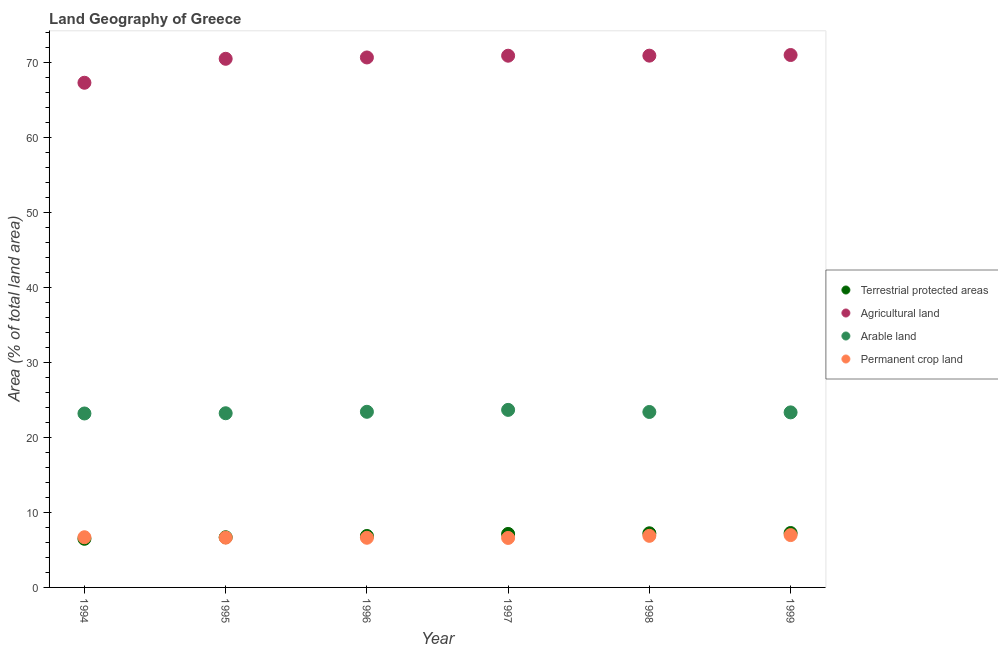How many different coloured dotlines are there?
Ensure brevity in your answer.  4. Is the number of dotlines equal to the number of legend labels?
Your answer should be very brief. Yes. What is the percentage of land under terrestrial protection in 1994?
Your answer should be very brief. 6.49. Across all years, what is the maximum percentage of area under arable land?
Provide a short and direct response. 23.69. Across all years, what is the minimum percentage of area under arable land?
Ensure brevity in your answer.  23.2. What is the total percentage of area under agricultural land in the graph?
Your answer should be compact. 421.44. What is the difference between the percentage of area under permanent crop land in 1994 and that in 1998?
Your answer should be compact. -0.19. What is the difference between the percentage of land under terrestrial protection in 1999 and the percentage of area under arable land in 1998?
Provide a short and direct response. -16.15. What is the average percentage of area under permanent crop land per year?
Offer a terse response. 6.74. In the year 1994, what is the difference between the percentage of area under permanent crop land and percentage of land under terrestrial protection?
Provide a short and direct response. 0.21. What is the ratio of the percentage of area under agricultural land in 1998 to that in 1999?
Make the answer very short. 1. What is the difference between the highest and the second highest percentage of area under arable land?
Give a very brief answer. 0.26. What is the difference between the highest and the lowest percentage of area under permanent crop land?
Make the answer very short. 0.38. Is it the case that in every year, the sum of the percentage of land under terrestrial protection and percentage of area under agricultural land is greater than the percentage of area under arable land?
Your answer should be very brief. Yes. Is the percentage of area under permanent crop land strictly greater than the percentage of land under terrestrial protection over the years?
Provide a succinct answer. No. Is the percentage of area under arable land strictly less than the percentage of land under terrestrial protection over the years?
Provide a succinct answer. No. What is the difference between two consecutive major ticks on the Y-axis?
Your answer should be compact. 10. What is the title of the graph?
Offer a very short reply. Land Geography of Greece. Does "Belgium" appear as one of the legend labels in the graph?
Provide a succinct answer. No. What is the label or title of the X-axis?
Offer a terse response. Year. What is the label or title of the Y-axis?
Your answer should be very brief. Area (% of total land area). What is the Area (% of total land area) of Terrestrial protected areas in 1994?
Your response must be concise. 6.49. What is the Area (% of total land area) of Agricultural land in 1994?
Provide a succinct answer. 67.32. What is the Area (% of total land area) of Arable land in 1994?
Provide a short and direct response. 23.2. What is the Area (% of total land area) of Permanent crop land in 1994?
Your response must be concise. 6.7. What is the Area (% of total land area) in Terrestrial protected areas in 1995?
Your answer should be compact. 6.69. What is the Area (% of total land area) in Agricultural land in 1995?
Make the answer very short. 70.52. What is the Area (% of total land area) in Arable land in 1995?
Provide a succinct answer. 23.24. What is the Area (% of total land area) in Permanent crop land in 1995?
Offer a very short reply. 6.64. What is the Area (% of total land area) of Terrestrial protected areas in 1996?
Your answer should be compact. 6.86. What is the Area (% of total land area) of Agricultural land in 1996?
Offer a terse response. 70.7. What is the Area (% of total land area) in Arable land in 1996?
Your answer should be compact. 23.43. What is the Area (% of total land area) in Permanent crop land in 1996?
Keep it short and to the point. 6.63. What is the Area (% of total land area) in Terrestrial protected areas in 1997?
Your response must be concise. 7.13. What is the Area (% of total land area) of Agricultural land in 1997?
Offer a very short reply. 70.93. What is the Area (% of total land area) of Arable land in 1997?
Provide a succinct answer. 23.69. What is the Area (% of total land area) in Permanent crop land in 1997?
Your answer should be compact. 6.6. What is the Area (% of total land area) in Terrestrial protected areas in 1998?
Provide a short and direct response. 7.22. What is the Area (% of total land area) in Agricultural land in 1998?
Give a very brief answer. 70.94. What is the Area (% of total land area) of Arable land in 1998?
Ensure brevity in your answer.  23.41. What is the Area (% of total land area) of Permanent crop land in 1998?
Keep it short and to the point. 6.88. What is the Area (% of total land area) in Terrestrial protected areas in 1999?
Your answer should be very brief. 7.26. What is the Area (% of total land area) of Agricultural land in 1999?
Your answer should be very brief. 71.02. What is the Area (% of total land area) in Arable land in 1999?
Your answer should be very brief. 23.35. What is the Area (% of total land area) in Permanent crop land in 1999?
Your answer should be very brief. 6.98. Across all years, what is the maximum Area (% of total land area) of Terrestrial protected areas?
Make the answer very short. 7.26. Across all years, what is the maximum Area (% of total land area) of Agricultural land?
Provide a short and direct response. 71.02. Across all years, what is the maximum Area (% of total land area) of Arable land?
Provide a short and direct response. 23.69. Across all years, what is the maximum Area (% of total land area) of Permanent crop land?
Your answer should be very brief. 6.98. Across all years, what is the minimum Area (% of total land area) of Terrestrial protected areas?
Provide a short and direct response. 6.49. Across all years, what is the minimum Area (% of total land area) of Agricultural land?
Your answer should be compact. 67.32. Across all years, what is the minimum Area (% of total land area) of Arable land?
Your answer should be compact. 23.2. Across all years, what is the minimum Area (% of total land area) in Permanent crop land?
Provide a short and direct response. 6.6. What is the total Area (% of total land area) of Terrestrial protected areas in the graph?
Keep it short and to the point. 41.65. What is the total Area (% of total land area) in Agricultural land in the graph?
Provide a short and direct response. 421.44. What is the total Area (% of total land area) in Arable land in the graph?
Ensure brevity in your answer.  140.31. What is the total Area (% of total land area) of Permanent crop land in the graph?
Keep it short and to the point. 40.43. What is the difference between the Area (% of total land area) of Terrestrial protected areas in 1994 and that in 1995?
Offer a terse response. -0.2. What is the difference between the Area (% of total land area) in Agricultural land in 1994 and that in 1995?
Offer a very short reply. -3.2. What is the difference between the Area (% of total land area) of Arable land in 1994 and that in 1995?
Your answer should be very brief. -0.03. What is the difference between the Area (% of total land area) in Permanent crop land in 1994 and that in 1995?
Make the answer very short. 0.05. What is the difference between the Area (% of total land area) of Terrestrial protected areas in 1994 and that in 1996?
Your answer should be compact. -0.37. What is the difference between the Area (% of total land area) in Agricultural land in 1994 and that in 1996?
Your answer should be compact. -3.37. What is the difference between the Area (% of total land area) of Arable land in 1994 and that in 1996?
Make the answer very short. -0.23. What is the difference between the Area (% of total land area) in Permanent crop land in 1994 and that in 1996?
Provide a short and direct response. 0.07. What is the difference between the Area (% of total land area) in Terrestrial protected areas in 1994 and that in 1997?
Provide a short and direct response. -0.65. What is the difference between the Area (% of total land area) of Agricultural land in 1994 and that in 1997?
Offer a very short reply. -3.61. What is the difference between the Area (% of total land area) of Arable land in 1994 and that in 1997?
Your response must be concise. -0.48. What is the difference between the Area (% of total land area) of Permanent crop land in 1994 and that in 1997?
Keep it short and to the point. 0.09. What is the difference between the Area (% of total land area) of Terrestrial protected areas in 1994 and that in 1998?
Provide a succinct answer. -0.73. What is the difference between the Area (% of total land area) of Agricultural land in 1994 and that in 1998?
Offer a terse response. -3.62. What is the difference between the Area (% of total land area) in Arable land in 1994 and that in 1998?
Your answer should be compact. -0.2. What is the difference between the Area (% of total land area) of Permanent crop land in 1994 and that in 1998?
Keep it short and to the point. -0.19. What is the difference between the Area (% of total land area) of Terrestrial protected areas in 1994 and that in 1999?
Ensure brevity in your answer.  -0.77. What is the difference between the Area (% of total land area) in Agricultural land in 1994 and that in 1999?
Your answer should be very brief. -3.7. What is the difference between the Area (% of total land area) of Arable land in 1994 and that in 1999?
Ensure brevity in your answer.  -0.15. What is the difference between the Area (% of total land area) of Permanent crop land in 1994 and that in 1999?
Give a very brief answer. -0.29. What is the difference between the Area (% of total land area) of Terrestrial protected areas in 1995 and that in 1996?
Offer a terse response. -0.17. What is the difference between the Area (% of total land area) of Agricultural land in 1995 and that in 1996?
Keep it short and to the point. -0.18. What is the difference between the Area (% of total land area) of Arable land in 1995 and that in 1996?
Give a very brief answer. -0.19. What is the difference between the Area (% of total land area) of Permanent crop land in 1995 and that in 1996?
Provide a succinct answer. 0.02. What is the difference between the Area (% of total land area) of Terrestrial protected areas in 1995 and that in 1997?
Offer a terse response. -0.44. What is the difference between the Area (% of total land area) of Agricultural land in 1995 and that in 1997?
Your answer should be compact. -0.41. What is the difference between the Area (% of total land area) in Arable land in 1995 and that in 1997?
Ensure brevity in your answer.  -0.45. What is the difference between the Area (% of total land area) in Permanent crop land in 1995 and that in 1997?
Offer a very short reply. 0.04. What is the difference between the Area (% of total land area) in Terrestrial protected areas in 1995 and that in 1998?
Offer a terse response. -0.53. What is the difference between the Area (% of total land area) in Agricultural land in 1995 and that in 1998?
Provide a short and direct response. -0.42. What is the difference between the Area (% of total land area) in Arable land in 1995 and that in 1998?
Make the answer very short. -0.17. What is the difference between the Area (% of total land area) of Permanent crop land in 1995 and that in 1998?
Offer a very short reply. -0.24. What is the difference between the Area (% of total land area) of Terrestrial protected areas in 1995 and that in 1999?
Provide a short and direct response. -0.56. What is the difference between the Area (% of total land area) in Agricultural land in 1995 and that in 1999?
Provide a succinct answer. -0.5. What is the difference between the Area (% of total land area) of Arable land in 1995 and that in 1999?
Your response must be concise. -0.12. What is the difference between the Area (% of total land area) in Permanent crop land in 1995 and that in 1999?
Offer a terse response. -0.34. What is the difference between the Area (% of total land area) of Terrestrial protected areas in 1996 and that in 1997?
Ensure brevity in your answer.  -0.27. What is the difference between the Area (% of total land area) of Agricultural land in 1996 and that in 1997?
Keep it short and to the point. -0.23. What is the difference between the Area (% of total land area) of Arable land in 1996 and that in 1997?
Provide a succinct answer. -0.26. What is the difference between the Area (% of total land area) in Permanent crop land in 1996 and that in 1997?
Offer a very short reply. 0.02. What is the difference between the Area (% of total land area) of Terrestrial protected areas in 1996 and that in 1998?
Offer a very short reply. -0.36. What is the difference between the Area (% of total land area) of Agricultural land in 1996 and that in 1998?
Provide a succinct answer. -0.24. What is the difference between the Area (% of total land area) of Arable land in 1996 and that in 1998?
Keep it short and to the point. 0.02. What is the difference between the Area (% of total land area) in Permanent crop land in 1996 and that in 1998?
Make the answer very short. -0.26. What is the difference between the Area (% of total land area) in Terrestrial protected areas in 1996 and that in 1999?
Keep it short and to the point. -0.4. What is the difference between the Area (% of total land area) of Agricultural land in 1996 and that in 1999?
Your response must be concise. -0.33. What is the difference between the Area (% of total land area) in Arable land in 1996 and that in 1999?
Your answer should be compact. 0.08. What is the difference between the Area (% of total land area) of Permanent crop land in 1996 and that in 1999?
Give a very brief answer. -0.36. What is the difference between the Area (% of total land area) in Terrestrial protected areas in 1997 and that in 1998?
Offer a terse response. -0.09. What is the difference between the Area (% of total land area) of Agricultural land in 1997 and that in 1998?
Provide a short and direct response. -0.01. What is the difference between the Area (% of total land area) in Arable land in 1997 and that in 1998?
Keep it short and to the point. 0.28. What is the difference between the Area (% of total land area) in Permanent crop land in 1997 and that in 1998?
Provide a short and direct response. -0.28. What is the difference between the Area (% of total land area) in Terrestrial protected areas in 1997 and that in 1999?
Offer a terse response. -0.12. What is the difference between the Area (% of total land area) of Agricultural land in 1997 and that in 1999?
Provide a short and direct response. -0.09. What is the difference between the Area (% of total land area) of Arable land in 1997 and that in 1999?
Make the answer very short. 0.33. What is the difference between the Area (% of total land area) of Permanent crop land in 1997 and that in 1999?
Make the answer very short. -0.38. What is the difference between the Area (% of total land area) in Terrestrial protected areas in 1998 and that in 1999?
Your answer should be very brief. -0.03. What is the difference between the Area (% of total land area) in Agricultural land in 1998 and that in 1999?
Your answer should be very brief. -0.09. What is the difference between the Area (% of total land area) of Arable land in 1998 and that in 1999?
Provide a short and direct response. 0.05. What is the difference between the Area (% of total land area) of Permanent crop land in 1998 and that in 1999?
Keep it short and to the point. -0.1. What is the difference between the Area (% of total land area) of Terrestrial protected areas in 1994 and the Area (% of total land area) of Agricultural land in 1995?
Offer a terse response. -64.03. What is the difference between the Area (% of total land area) of Terrestrial protected areas in 1994 and the Area (% of total land area) of Arable land in 1995?
Provide a short and direct response. -16.75. What is the difference between the Area (% of total land area) of Terrestrial protected areas in 1994 and the Area (% of total land area) of Permanent crop land in 1995?
Your answer should be very brief. -0.15. What is the difference between the Area (% of total land area) in Agricultural land in 1994 and the Area (% of total land area) in Arable land in 1995?
Give a very brief answer. 44.09. What is the difference between the Area (% of total land area) of Agricultural land in 1994 and the Area (% of total land area) of Permanent crop land in 1995?
Offer a terse response. 60.68. What is the difference between the Area (% of total land area) of Arable land in 1994 and the Area (% of total land area) of Permanent crop land in 1995?
Offer a terse response. 16.56. What is the difference between the Area (% of total land area) in Terrestrial protected areas in 1994 and the Area (% of total land area) in Agricultural land in 1996?
Ensure brevity in your answer.  -64.21. What is the difference between the Area (% of total land area) in Terrestrial protected areas in 1994 and the Area (% of total land area) in Arable land in 1996?
Your response must be concise. -16.94. What is the difference between the Area (% of total land area) in Terrestrial protected areas in 1994 and the Area (% of total land area) in Permanent crop land in 1996?
Your answer should be very brief. -0.14. What is the difference between the Area (% of total land area) in Agricultural land in 1994 and the Area (% of total land area) in Arable land in 1996?
Give a very brief answer. 43.89. What is the difference between the Area (% of total land area) in Agricultural land in 1994 and the Area (% of total land area) in Permanent crop land in 1996?
Ensure brevity in your answer.  60.7. What is the difference between the Area (% of total land area) in Arable land in 1994 and the Area (% of total land area) in Permanent crop land in 1996?
Provide a short and direct response. 16.58. What is the difference between the Area (% of total land area) of Terrestrial protected areas in 1994 and the Area (% of total land area) of Agricultural land in 1997?
Ensure brevity in your answer.  -64.44. What is the difference between the Area (% of total land area) in Terrestrial protected areas in 1994 and the Area (% of total land area) in Arable land in 1997?
Provide a short and direct response. -17.2. What is the difference between the Area (% of total land area) in Terrestrial protected areas in 1994 and the Area (% of total land area) in Permanent crop land in 1997?
Make the answer very short. -0.11. What is the difference between the Area (% of total land area) in Agricultural land in 1994 and the Area (% of total land area) in Arable land in 1997?
Your answer should be very brief. 43.64. What is the difference between the Area (% of total land area) of Agricultural land in 1994 and the Area (% of total land area) of Permanent crop land in 1997?
Offer a terse response. 60.72. What is the difference between the Area (% of total land area) in Arable land in 1994 and the Area (% of total land area) in Permanent crop land in 1997?
Offer a very short reply. 16.6. What is the difference between the Area (% of total land area) in Terrestrial protected areas in 1994 and the Area (% of total land area) in Agricultural land in 1998?
Make the answer very short. -64.45. What is the difference between the Area (% of total land area) of Terrestrial protected areas in 1994 and the Area (% of total land area) of Arable land in 1998?
Provide a short and direct response. -16.92. What is the difference between the Area (% of total land area) of Terrestrial protected areas in 1994 and the Area (% of total land area) of Permanent crop land in 1998?
Keep it short and to the point. -0.39. What is the difference between the Area (% of total land area) of Agricultural land in 1994 and the Area (% of total land area) of Arable land in 1998?
Your response must be concise. 43.92. What is the difference between the Area (% of total land area) in Agricultural land in 1994 and the Area (% of total land area) in Permanent crop land in 1998?
Provide a succinct answer. 60.44. What is the difference between the Area (% of total land area) in Arable land in 1994 and the Area (% of total land area) in Permanent crop land in 1998?
Offer a very short reply. 16.32. What is the difference between the Area (% of total land area) of Terrestrial protected areas in 1994 and the Area (% of total land area) of Agricultural land in 1999?
Provide a short and direct response. -64.54. What is the difference between the Area (% of total land area) of Terrestrial protected areas in 1994 and the Area (% of total land area) of Arable land in 1999?
Ensure brevity in your answer.  -16.86. What is the difference between the Area (% of total land area) of Terrestrial protected areas in 1994 and the Area (% of total land area) of Permanent crop land in 1999?
Give a very brief answer. -0.49. What is the difference between the Area (% of total land area) in Agricultural land in 1994 and the Area (% of total land area) in Arable land in 1999?
Offer a terse response. 43.97. What is the difference between the Area (% of total land area) of Agricultural land in 1994 and the Area (% of total land area) of Permanent crop land in 1999?
Give a very brief answer. 60.34. What is the difference between the Area (% of total land area) in Arable land in 1994 and the Area (% of total land area) in Permanent crop land in 1999?
Your answer should be very brief. 16.22. What is the difference between the Area (% of total land area) of Terrestrial protected areas in 1995 and the Area (% of total land area) of Agricultural land in 1996?
Offer a very short reply. -64.01. What is the difference between the Area (% of total land area) of Terrestrial protected areas in 1995 and the Area (% of total land area) of Arable land in 1996?
Offer a terse response. -16.74. What is the difference between the Area (% of total land area) of Terrestrial protected areas in 1995 and the Area (% of total land area) of Permanent crop land in 1996?
Your answer should be very brief. 0.07. What is the difference between the Area (% of total land area) in Agricultural land in 1995 and the Area (% of total land area) in Arable land in 1996?
Offer a terse response. 47.09. What is the difference between the Area (% of total land area) of Agricultural land in 1995 and the Area (% of total land area) of Permanent crop land in 1996?
Offer a terse response. 63.89. What is the difference between the Area (% of total land area) in Arable land in 1995 and the Area (% of total land area) in Permanent crop land in 1996?
Your answer should be compact. 16.61. What is the difference between the Area (% of total land area) in Terrestrial protected areas in 1995 and the Area (% of total land area) in Agricultural land in 1997?
Provide a short and direct response. -64.24. What is the difference between the Area (% of total land area) in Terrestrial protected areas in 1995 and the Area (% of total land area) in Arable land in 1997?
Keep it short and to the point. -16.99. What is the difference between the Area (% of total land area) of Terrestrial protected areas in 1995 and the Area (% of total land area) of Permanent crop land in 1997?
Ensure brevity in your answer.  0.09. What is the difference between the Area (% of total land area) in Agricultural land in 1995 and the Area (% of total land area) in Arable land in 1997?
Offer a very short reply. 46.83. What is the difference between the Area (% of total land area) of Agricultural land in 1995 and the Area (% of total land area) of Permanent crop land in 1997?
Ensure brevity in your answer.  63.92. What is the difference between the Area (% of total land area) in Arable land in 1995 and the Area (% of total land area) in Permanent crop land in 1997?
Keep it short and to the point. 16.63. What is the difference between the Area (% of total land area) of Terrestrial protected areas in 1995 and the Area (% of total land area) of Agricultural land in 1998?
Give a very brief answer. -64.25. What is the difference between the Area (% of total land area) of Terrestrial protected areas in 1995 and the Area (% of total land area) of Arable land in 1998?
Your answer should be compact. -16.71. What is the difference between the Area (% of total land area) of Terrestrial protected areas in 1995 and the Area (% of total land area) of Permanent crop land in 1998?
Your response must be concise. -0.19. What is the difference between the Area (% of total land area) in Agricultural land in 1995 and the Area (% of total land area) in Arable land in 1998?
Provide a succinct answer. 47.11. What is the difference between the Area (% of total land area) of Agricultural land in 1995 and the Area (% of total land area) of Permanent crop land in 1998?
Offer a very short reply. 63.64. What is the difference between the Area (% of total land area) in Arable land in 1995 and the Area (% of total land area) in Permanent crop land in 1998?
Offer a very short reply. 16.35. What is the difference between the Area (% of total land area) in Terrestrial protected areas in 1995 and the Area (% of total land area) in Agricultural land in 1999?
Ensure brevity in your answer.  -64.33. What is the difference between the Area (% of total land area) in Terrestrial protected areas in 1995 and the Area (% of total land area) in Arable land in 1999?
Provide a succinct answer. -16.66. What is the difference between the Area (% of total land area) of Terrestrial protected areas in 1995 and the Area (% of total land area) of Permanent crop land in 1999?
Your answer should be very brief. -0.29. What is the difference between the Area (% of total land area) in Agricultural land in 1995 and the Area (% of total land area) in Arable land in 1999?
Keep it short and to the point. 47.17. What is the difference between the Area (% of total land area) in Agricultural land in 1995 and the Area (% of total land area) in Permanent crop land in 1999?
Your response must be concise. 63.54. What is the difference between the Area (% of total land area) in Arable land in 1995 and the Area (% of total land area) in Permanent crop land in 1999?
Keep it short and to the point. 16.25. What is the difference between the Area (% of total land area) in Terrestrial protected areas in 1996 and the Area (% of total land area) in Agricultural land in 1997?
Offer a terse response. -64.07. What is the difference between the Area (% of total land area) of Terrestrial protected areas in 1996 and the Area (% of total land area) of Arable land in 1997?
Your answer should be compact. -16.82. What is the difference between the Area (% of total land area) in Terrestrial protected areas in 1996 and the Area (% of total land area) in Permanent crop land in 1997?
Give a very brief answer. 0.26. What is the difference between the Area (% of total land area) in Agricultural land in 1996 and the Area (% of total land area) in Arable land in 1997?
Offer a very short reply. 47.01. What is the difference between the Area (% of total land area) of Agricultural land in 1996 and the Area (% of total land area) of Permanent crop land in 1997?
Ensure brevity in your answer.  64.1. What is the difference between the Area (% of total land area) in Arable land in 1996 and the Area (% of total land area) in Permanent crop land in 1997?
Give a very brief answer. 16.83. What is the difference between the Area (% of total land area) of Terrestrial protected areas in 1996 and the Area (% of total land area) of Agricultural land in 1998?
Give a very brief answer. -64.08. What is the difference between the Area (% of total land area) in Terrestrial protected areas in 1996 and the Area (% of total land area) in Arable land in 1998?
Give a very brief answer. -16.55. What is the difference between the Area (% of total land area) in Terrestrial protected areas in 1996 and the Area (% of total land area) in Permanent crop land in 1998?
Your response must be concise. -0.02. What is the difference between the Area (% of total land area) of Agricultural land in 1996 and the Area (% of total land area) of Arable land in 1998?
Your answer should be compact. 47.29. What is the difference between the Area (% of total land area) in Agricultural land in 1996 and the Area (% of total land area) in Permanent crop land in 1998?
Your response must be concise. 63.82. What is the difference between the Area (% of total land area) in Arable land in 1996 and the Area (% of total land area) in Permanent crop land in 1998?
Offer a very short reply. 16.55. What is the difference between the Area (% of total land area) in Terrestrial protected areas in 1996 and the Area (% of total land area) in Agricultural land in 1999?
Keep it short and to the point. -64.16. What is the difference between the Area (% of total land area) in Terrestrial protected areas in 1996 and the Area (% of total land area) in Arable land in 1999?
Your answer should be compact. -16.49. What is the difference between the Area (% of total land area) of Terrestrial protected areas in 1996 and the Area (% of total land area) of Permanent crop land in 1999?
Keep it short and to the point. -0.12. What is the difference between the Area (% of total land area) of Agricultural land in 1996 and the Area (% of total land area) of Arable land in 1999?
Offer a very short reply. 47.35. What is the difference between the Area (% of total land area) in Agricultural land in 1996 and the Area (% of total land area) in Permanent crop land in 1999?
Your answer should be very brief. 63.72. What is the difference between the Area (% of total land area) in Arable land in 1996 and the Area (% of total land area) in Permanent crop land in 1999?
Give a very brief answer. 16.45. What is the difference between the Area (% of total land area) in Terrestrial protected areas in 1997 and the Area (% of total land area) in Agricultural land in 1998?
Give a very brief answer. -63.8. What is the difference between the Area (% of total land area) in Terrestrial protected areas in 1997 and the Area (% of total land area) in Arable land in 1998?
Your answer should be very brief. -16.27. What is the difference between the Area (% of total land area) of Terrestrial protected areas in 1997 and the Area (% of total land area) of Permanent crop land in 1998?
Give a very brief answer. 0.25. What is the difference between the Area (% of total land area) in Agricultural land in 1997 and the Area (% of total land area) in Arable land in 1998?
Your answer should be compact. 47.53. What is the difference between the Area (% of total land area) in Agricultural land in 1997 and the Area (% of total land area) in Permanent crop land in 1998?
Your response must be concise. 64.05. What is the difference between the Area (% of total land area) in Arable land in 1997 and the Area (% of total land area) in Permanent crop land in 1998?
Your response must be concise. 16.8. What is the difference between the Area (% of total land area) of Terrestrial protected areas in 1997 and the Area (% of total land area) of Agricultural land in 1999?
Provide a succinct answer. -63.89. What is the difference between the Area (% of total land area) in Terrestrial protected areas in 1997 and the Area (% of total land area) in Arable land in 1999?
Provide a succinct answer. -16.22. What is the difference between the Area (% of total land area) in Terrestrial protected areas in 1997 and the Area (% of total land area) in Permanent crop land in 1999?
Provide a short and direct response. 0.15. What is the difference between the Area (% of total land area) of Agricultural land in 1997 and the Area (% of total land area) of Arable land in 1999?
Your answer should be compact. 47.58. What is the difference between the Area (% of total land area) in Agricultural land in 1997 and the Area (% of total land area) in Permanent crop land in 1999?
Provide a short and direct response. 63.95. What is the difference between the Area (% of total land area) in Arable land in 1997 and the Area (% of total land area) in Permanent crop land in 1999?
Offer a very short reply. 16.7. What is the difference between the Area (% of total land area) in Terrestrial protected areas in 1998 and the Area (% of total land area) in Agricultural land in 1999?
Your answer should be very brief. -63.8. What is the difference between the Area (% of total land area) in Terrestrial protected areas in 1998 and the Area (% of total land area) in Arable land in 1999?
Your response must be concise. -16.13. What is the difference between the Area (% of total land area) in Terrestrial protected areas in 1998 and the Area (% of total land area) in Permanent crop land in 1999?
Keep it short and to the point. 0.24. What is the difference between the Area (% of total land area) in Agricultural land in 1998 and the Area (% of total land area) in Arable land in 1999?
Keep it short and to the point. 47.59. What is the difference between the Area (% of total land area) in Agricultural land in 1998 and the Area (% of total land area) in Permanent crop land in 1999?
Give a very brief answer. 63.96. What is the difference between the Area (% of total land area) of Arable land in 1998 and the Area (% of total land area) of Permanent crop land in 1999?
Your answer should be very brief. 16.42. What is the average Area (% of total land area) of Terrestrial protected areas per year?
Provide a short and direct response. 6.94. What is the average Area (% of total land area) of Agricultural land per year?
Give a very brief answer. 70.24. What is the average Area (% of total land area) of Arable land per year?
Provide a succinct answer. 23.39. What is the average Area (% of total land area) of Permanent crop land per year?
Offer a very short reply. 6.74. In the year 1994, what is the difference between the Area (% of total land area) of Terrestrial protected areas and Area (% of total land area) of Agricultural land?
Keep it short and to the point. -60.84. In the year 1994, what is the difference between the Area (% of total land area) in Terrestrial protected areas and Area (% of total land area) in Arable land?
Your response must be concise. -16.72. In the year 1994, what is the difference between the Area (% of total land area) in Terrestrial protected areas and Area (% of total land area) in Permanent crop land?
Offer a terse response. -0.21. In the year 1994, what is the difference between the Area (% of total land area) in Agricultural land and Area (% of total land area) in Arable land?
Ensure brevity in your answer.  44.12. In the year 1994, what is the difference between the Area (% of total land area) in Agricultural land and Area (% of total land area) in Permanent crop land?
Ensure brevity in your answer.  60.63. In the year 1994, what is the difference between the Area (% of total land area) in Arable land and Area (% of total land area) in Permanent crop land?
Give a very brief answer. 16.51. In the year 1995, what is the difference between the Area (% of total land area) in Terrestrial protected areas and Area (% of total land area) in Agricultural land?
Your answer should be very brief. -63.83. In the year 1995, what is the difference between the Area (% of total land area) in Terrestrial protected areas and Area (% of total land area) in Arable land?
Make the answer very short. -16.54. In the year 1995, what is the difference between the Area (% of total land area) of Terrestrial protected areas and Area (% of total land area) of Permanent crop land?
Give a very brief answer. 0.05. In the year 1995, what is the difference between the Area (% of total land area) of Agricultural land and Area (% of total land area) of Arable land?
Provide a succinct answer. 47.28. In the year 1995, what is the difference between the Area (% of total land area) of Agricultural land and Area (% of total land area) of Permanent crop land?
Your response must be concise. 63.88. In the year 1995, what is the difference between the Area (% of total land area) of Arable land and Area (% of total land area) of Permanent crop land?
Offer a very short reply. 16.59. In the year 1996, what is the difference between the Area (% of total land area) in Terrestrial protected areas and Area (% of total land area) in Agricultural land?
Your response must be concise. -63.84. In the year 1996, what is the difference between the Area (% of total land area) in Terrestrial protected areas and Area (% of total land area) in Arable land?
Offer a terse response. -16.57. In the year 1996, what is the difference between the Area (% of total land area) of Terrestrial protected areas and Area (% of total land area) of Permanent crop land?
Offer a very short reply. 0.24. In the year 1996, what is the difference between the Area (% of total land area) of Agricultural land and Area (% of total land area) of Arable land?
Your answer should be compact. 47.27. In the year 1996, what is the difference between the Area (% of total land area) in Agricultural land and Area (% of total land area) in Permanent crop land?
Offer a terse response. 64.07. In the year 1996, what is the difference between the Area (% of total land area) of Arable land and Area (% of total land area) of Permanent crop land?
Make the answer very short. 16.8. In the year 1997, what is the difference between the Area (% of total land area) in Terrestrial protected areas and Area (% of total land area) in Agricultural land?
Offer a terse response. -63.8. In the year 1997, what is the difference between the Area (% of total land area) in Terrestrial protected areas and Area (% of total land area) in Arable land?
Your response must be concise. -16.55. In the year 1997, what is the difference between the Area (% of total land area) of Terrestrial protected areas and Area (% of total land area) of Permanent crop land?
Offer a terse response. 0.53. In the year 1997, what is the difference between the Area (% of total land area) of Agricultural land and Area (% of total land area) of Arable land?
Provide a short and direct response. 47.25. In the year 1997, what is the difference between the Area (% of total land area) in Agricultural land and Area (% of total land area) in Permanent crop land?
Provide a succinct answer. 64.33. In the year 1997, what is the difference between the Area (% of total land area) of Arable land and Area (% of total land area) of Permanent crop land?
Your answer should be compact. 17.08. In the year 1998, what is the difference between the Area (% of total land area) in Terrestrial protected areas and Area (% of total land area) in Agricultural land?
Your answer should be very brief. -63.72. In the year 1998, what is the difference between the Area (% of total land area) in Terrestrial protected areas and Area (% of total land area) in Arable land?
Offer a very short reply. -16.18. In the year 1998, what is the difference between the Area (% of total land area) of Terrestrial protected areas and Area (% of total land area) of Permanent crop land?
Ensure brevity in your answer.  0.34. In the year 1998, what is the difference between the Area (% of total land area) of Agricultural land and Area (% of total land area) of Arable land?
Provide a short and direct response. 47.53. In the year 1998, what is the difference between the Area (% of total land area) of Agricultural land and Area (% of total land area) of Permanent crop land?
Offer a very short reply. 64.06. In the year 1998, what is the difference between the Area (% of total land area) of Arable land and Area (% of total land area) of Permanent crop land?
Make the answer very short. 16.52. In the year 1999, what is the difference between the Area (% of total land area) in Terrestrial protected areas and Area (% of total land area) in Agricultural land?
Keep it short and to the point. -63.77. In the year 1999, what is the difference between the Area (% of total land area) of Terrestrial protected areas and Area (% of total land area) of Arable land?
Provide a succinct answer. -16.09. In the year 1999, what is the difference between the Area (% of total land area) of Terrestrial protected areas and Area (% of total land area) of Permanent crop land?
Give a very brief answer. 0.27. In the year 1999, what is the difference between the Area (% of total land area) of Agricultural land and Area (% of total land area) of Arable land?
Make the answer very short. 47.67. In the year 1999, what is the difference between the Area (% of total land area) of Agricultural land and Area (% of total land area) of Permanent crop land?
Provide a succinct answer. 64.04. In the year 1999, what is the difference between the Area (% of total land area) in Arable land and Area (% of total land area) in Permanent crop land?
Your response must be concise. 16.37. What is the ratio of the Area (% of total land area) in Terrestrial protected areas in 1994 to that in 1995?
Your answer should be compact. 0.97. What is the ratio of the Area (% of total land area) of Agricultural land in 1994 to that in 1995?
Provide a succinct answer. 0.95. What is the ratio of the Area (% of total land area) of Permanent crop land in 1994 to that in 1995?
Provide a short and direct response. 1.01. What is the ratio of the Area (% of total land area) of Terrestrial protected areas in 1994 to that in 1996?
Make the answer very short. 0.95. What is the ratio of the Area (% of total land area) of Agricultural land in 1994 to that in 1996?
Provide a short and direct response. 0.95. What is the ratio of the Area (% of total land area) in Permanent crop land in 1994 to that in 1996?
Provide a succinct answer. 1.01. What is the ratio of the Area (% of total land area) of Terrestrial protected areas in 1994 to that in 1997?
Give a very brief answer. 0.91. What is the ratio of the Area (% of total land area) in Agricultural land in 1994 to that in 1997?
Ensure brevity in your answer.  0.95. What is the ratio of the Area (% of total land area) in Arable land in 1994 to that in 1997?
Your answer should be very brief. 0.98. What is the ratio of the Area (% of total land area) of Permanent crop land in 1994 to that in 1997?
Give a very brief answer. 1.01. What is the ratio of the Area (% of total land area) of Terrestrial protected areas in 1994 to that in 1998?
Provide a short and direct response. 0.9. What is the ratio of the Area (% of total land area) in Agricultural land in 1994 to that in 1998?
Ensure brevity in your answer.  0.95. What is the ratio of the Area (% of total land area) in Arable land in 1994 to that in 1998?
Your answer should be very brief. 0.99. What is the ratio of the Area (% of total land area) in Permanent crop land in 1994 to that in 1998?
Give a very brief answer. 0.97. What is the ratio of the Area (% of total land area) in Terrestrial protected areas in 1994 to that in 1999?
Your answer should be very brief. 0.89. What is the ratio of the Area (% of total land area) of Agricultural land in 1994 to that in 1999?
Keep it short and to the point. 0.95. What is the ratio of the Area (% of total land area) of Arable land in 1994 to that in 1999?
Offer a terse response. 0.99. What is the ratio of the Area (% of total land area) of Permanent crop land in 1994 to that in 1999?
Offer a terse response. 0.96. What is the ratio of the Area (% of total land area) of Terrestrial protected areas in 1995 to that in 1996?
Give a very brief answer. 0.98. What is the ratio of the Area (% of total land area) of Arable land in 1995 to that in 1996?
Provide a succinct answer. 0.99. What is the ratio of the Area (% of total land area) of Terrestrial protected areas in 1995 to that in 1997?
Offer a terse response. 0.94. What is the ratio of the Area (% of total land area) of Agricultural land in 1995 to that in 1997?
Offer a terse response. 0.99. What is the ratio of the Area (% of total land area) in Arable land in 1995 to that in 1997?
Keep it short and to the point. 0.98. What is the ratio of the Area (% of total land area) of Permanent crop land in 1995 to that in 1997?
Keep it short and to the point. 1.01. What is the ratio of the Area (% of total land area) of Terrestrial protected areas in 1995 to that in 1998?
Make the answer very short. 0.93. What is the ratio of the Area (% of total land area) of Agricultural land in 1995 to that in 1998?
Offer a terse response. 0.99. What is the ratio of the Area (% of total land area) of Permanent crop land in 1995 to that in 1998?
Give a very brief answer. 0.97. What is the ratio of the Area (% of total land area) in Terrestrial protected areas in 1995 to that in 1999?
Ensure brevity in your answer.  0.92. What is the ratio of the Area (% of total land area) of Arable land in 1995 to that in 1999?
Keep it short and to the point. 0.99. What is the ratio of the Area (% of total land area) in Permanent crop land in 1995 to that in 1999?
Give a very brief answer. 0.95. What is the ratio of the Area (% of total land area) of Terrestrial protected areas in 1996 to that in 1997?
Give a very brief answer. 0.96. What is the ratio of the Area (% of total land area) in Terrestrial protected areas in 1996 to that in 1998?
Give a very brief answer. 0.95. What is the ratio of the Area (% of total land area) of Arable land in 1996 to that in 1998?
Offer a terse response. 1. What is the ratio of the Area (% of total land area) in Permanent crop land in 1996 to that in 1998?
Give a very brief answer. 0.96. What is the ratio of the Area (% of total land area) of Terrestrial protected areas in 1996 to that in 1999?
Your answer should be compact. 0.95. What is the ratio of the Area (% of total land area) of Permanent crop land in 1996 to that in 1999?
Provide a short and direct response. 0.95. What is the ratio of the Area (% of total land area) of Terrestrial protected areas in 1997 to that in 1998?
Your response must be concise. 0.99. What is the ratio of the Area (% of total land area) of Agricultural land in 1997 to that in 1998?
Ensure brevity in your answer.  1. What is the ratio of the Area (% of total land area) of Arable land in 1997 to that in 1998?
Provide a short and direct response. 1.01. What is the ratio of the Area (% of total land area) of Permanent crop land in 1997 to that in 1998?
Provide a short and direct response. 0.96. What is the ratio of the Area (% of total land area) of Terrestrial protected areas in 1997 to that in 1999?
Provide a succinct answer. 0.98. What is the ratio of the Area (% of total land area) in Arable land in 1997 to that in 1999?
Offer a very short reply. 1.01. What is the ratio of the Area (% of total land area) in Permanent crop land in 1997 to that in 1999?
Offer a very short reply. 0.95. What is the ratio of the Area (% of total land area) of Terrestrial protected areas in 1998 to that in 1999?
Ensure brevity in your answer.  1. What is the ratio of the Area (% of total land area) of Agricultural land in 1998 to that in 1999?
Provide a short and direct response. 1. What is the ratio of the Area (% of total land area) in Arable land in 1998 to that in 1999?
Provide a short and direct response. 1. What is the ratio of the Area (% of total land area) of Permanent crop land in 1998 to that in 1999?
Offer a terse response. 0.99. What is the difference between the highest and the second highest Area (% of total land area) of Terrestrial protected areas?
Provide a succinct answer. 0.03. What is the difference between the highest and the second highest Area (% of total land area) of Agricultural land?
Your response must be concise. 0.09. What is the difference between the highest and the second highest Area (% of total land area) of Arable land?
Your response must be concise. 0.26. What is the difference between the highest and the second highest Area (% of total land area) in Permanent crop land?
Give a very brief answer. 0.1. What is the difference between the highest and the lowest Area (% of total land area) in Terrestrial protected areas?
Offer a terse response. 0.77. What is the difference between the highest and the lowest Area (% of total land area) of Agricultural land?
Your answer should be very brief. 3.7. What is the difference between the highest and the lowest Area (% of total land area) in Arable land?
Make the answer very short. 0.48. What is the difference between the highest and the lowest Area (% of total land area) in Permanent crop land?
Keep it short and to the point. 0.38. 